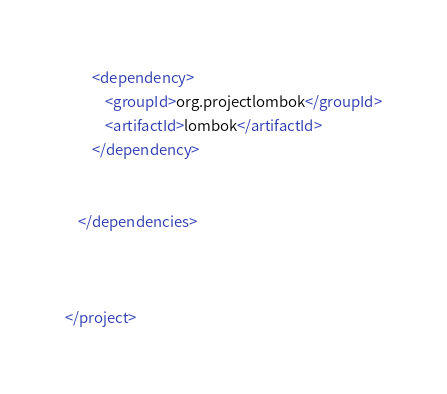Convert code to text. <code><loc_0><loc_0><loc_500><loc_500><_XML_>        <dependency>
            <groupId>org.projectlombok</groupId>
            <artifactId>lombok</artifactId>
        </dependency>


    </dependencies>



</project></code> 